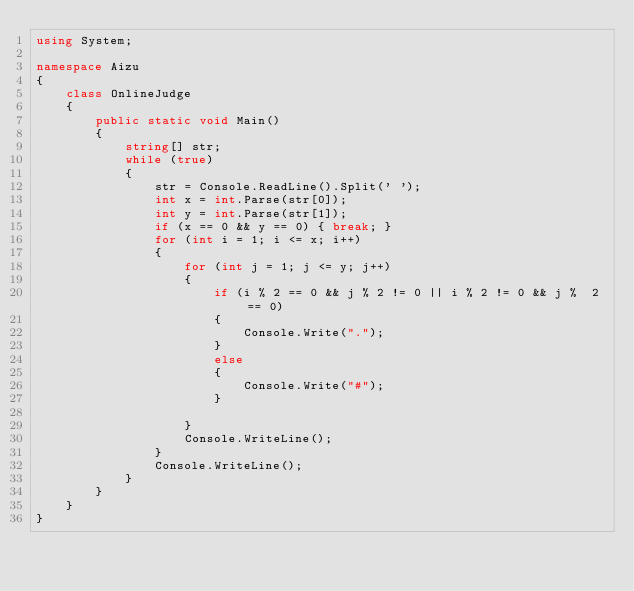<code> <loc_0><loc_0><loc_500><loc_500><_C#_>using System;

namespace Aizu
{
    class OnlineJudge
    {
        public static void Main()
        {
            string[] str;
            while (true)
            {
                str = Console.ReadLine().Split(' ');
                int x = int.Parse(str[0]);
                int y = int.Parse(str[1]);
                if (x == 0 && y == 0) { break; }
                for (int i = 1; i <= x; i++)
                {
                    for (int j = 1; j <= y; j++)
                    {
                        if (i % 2 == 0 && j % 2 != 0 || i % 2 != 0 && j %  2 == 0)
                        {
                            Console.Write(".");
                        }
                        else
                        {
                            Console.Write("#");
                        }

                    }
                    Console.WriteLine();
                }
                Console.WriteLine();
            }
        }
    }
}

</code> 